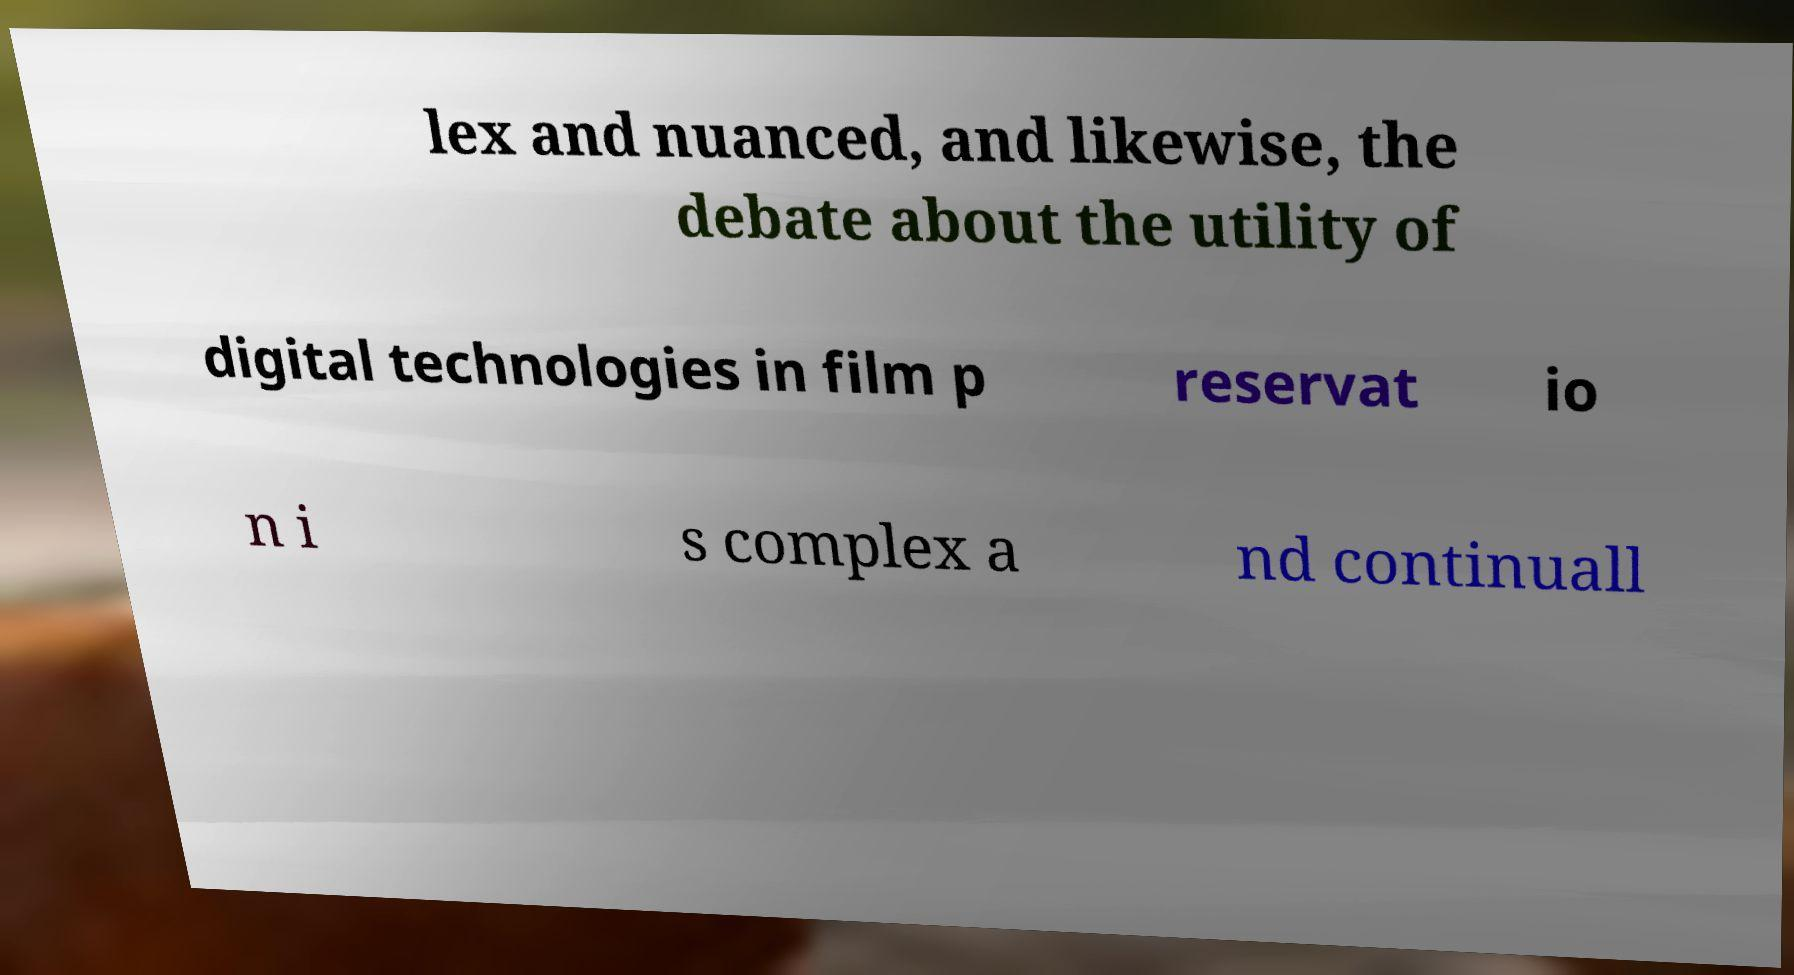Please read and relay the text visible in this image. What does it say? lex and nuanced, and likewise, the debate about the utility of digital technologies in film p reservat io n i s complex a nd continuall 